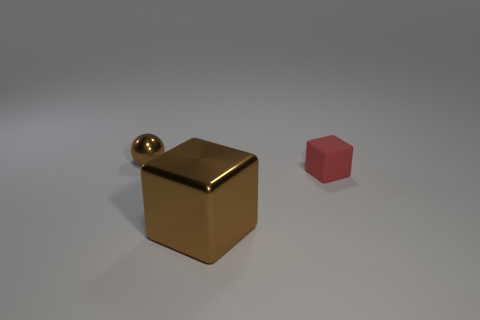Do the small ball and the small object on the right side of the big cube have the same material?
Provide a short and direct response. No. Are there more tiny brown objects than small yellow shiny cylinders?
Your response must be concise. Yes. How many balls are big things or small metallic things?
Provide a short and direct response. 1. The metal cube is what color?
Provide a short and direct response. Brown. Does the brown object in front of the ball have the same size as the metal thing that is on the left side of the brown shiny cube?
Make the answer very short. No. Is the number of small red objects less than the number of blocks?
Give a very brief answer. Yes. There is a big metal block; how many tiny shiny things are to the right of it?
Offer a terse response. 0. What is the tiny block made of?
Provide a short and direct response. Rubber. Is the large cube the same color as the rubber object?
Your response must be concise. No. Are there fewer tiny blocks that are behind the matte object than blocks?
Provide a succinct answer. Yes. 